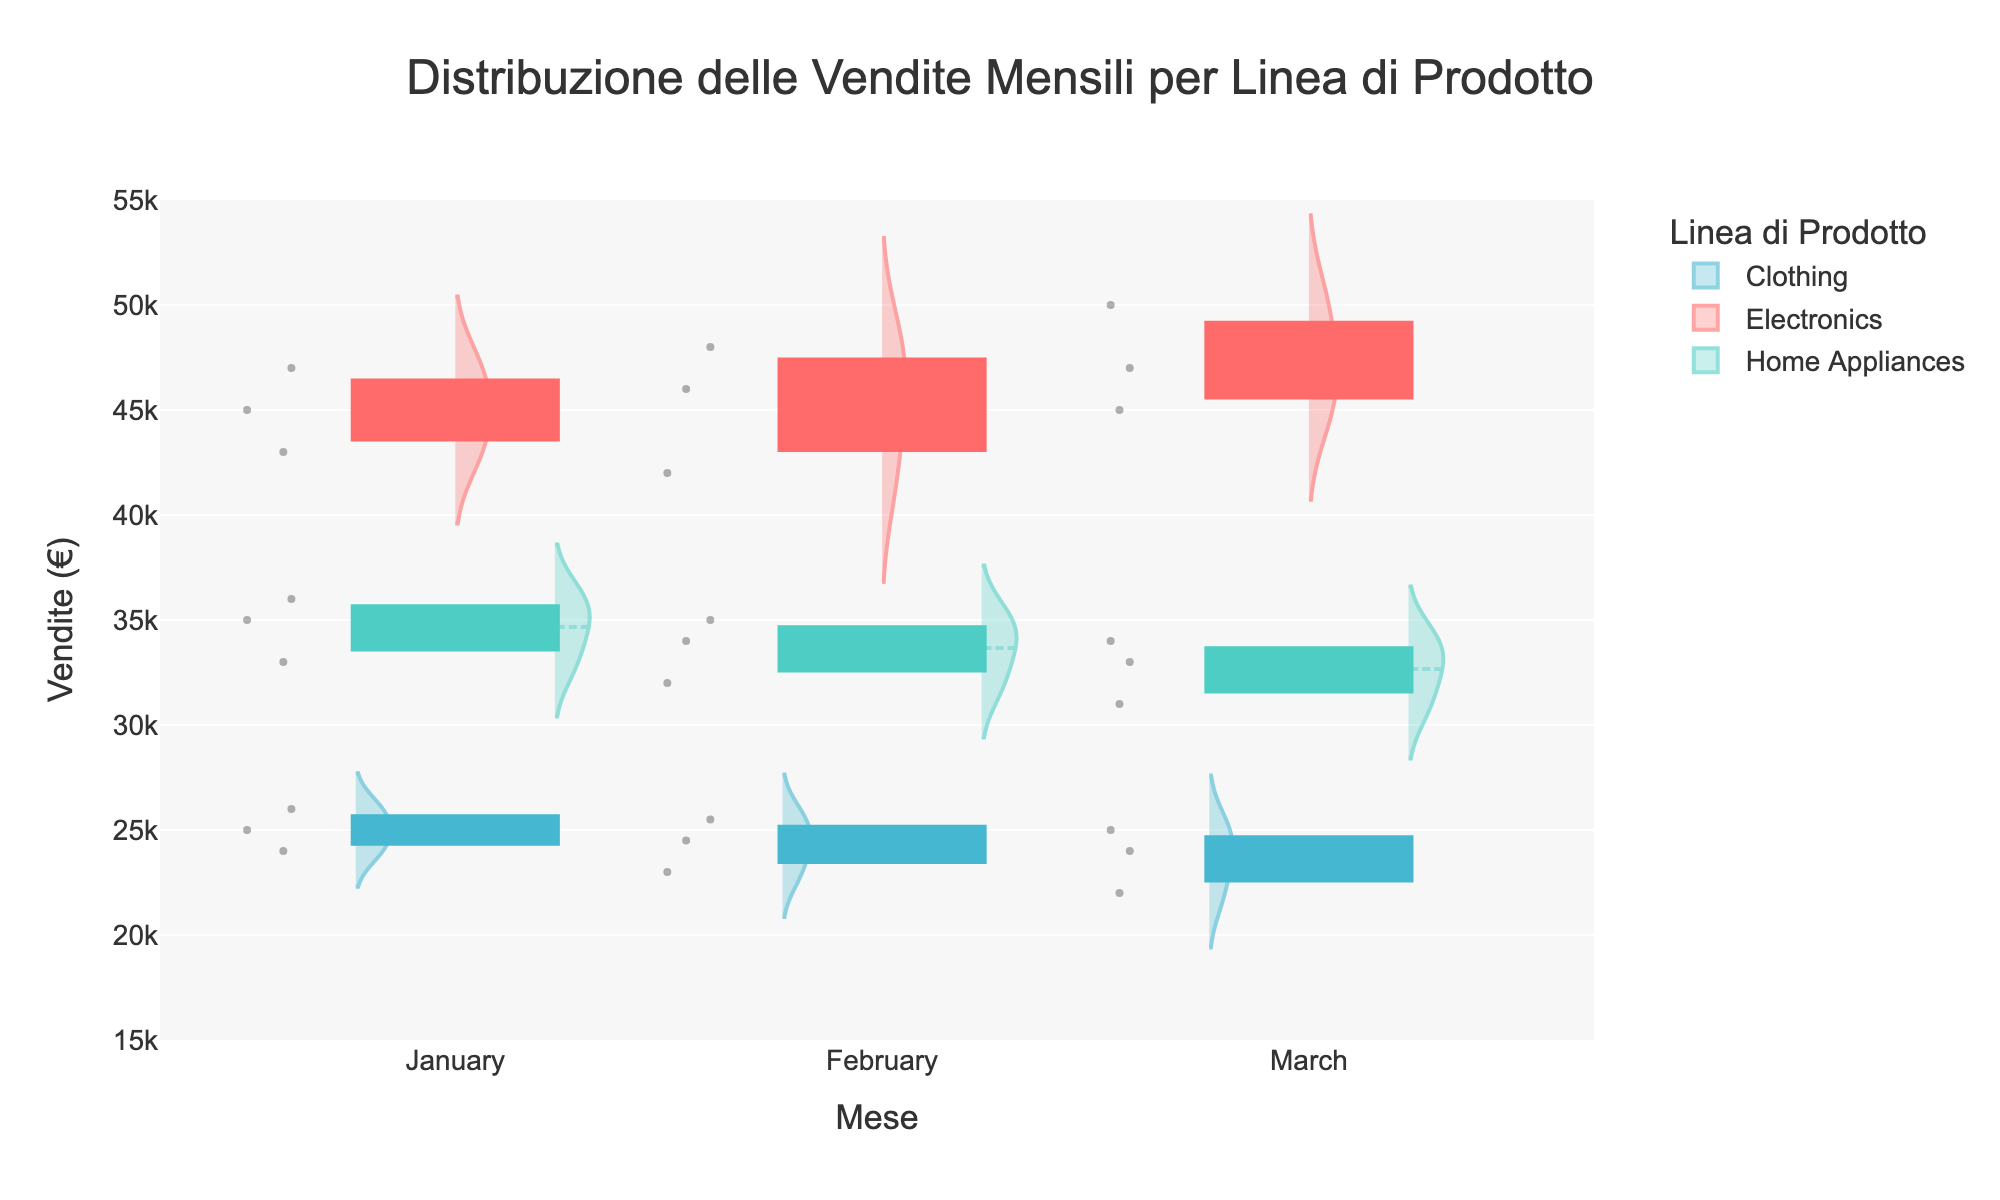What is the title of the figure? The title is positioned at the top of the figure. It reads "Distribuzione delle Vendite Mensili per Linea di Prodotto".
Answer: Distribuzione delle Vendite Mensili per Linea di Prodotto Which month has the highest sales for Electronics? In the figure, look at the median lines within the violins for each month under Electronics. The March median line is higher than those in January and February.
Answer: March What are the colors used for each product line? Refer to the legend on the right side of the figure. Electronics is red, Home Appliances is green, and Clothing is blue.
Answer: Electronics: Red, Home Appliances: Green, Clothing: Blue Which product line shows the widest range of sales values in March? Check the width of each violin plot for each product line in March. The Electronics violin plot is the widest, indicating the largest spread of sales values.
Answer: Electronics What is the median sales value for Clothing in February? Locate the Clothing violin plot for February. The median value is shown by a dashed line inside the violin. It appears near €24,500.
Answer: €24,500 Are sales values for Home Appliances more consistent in January or February? Look at the Home Appliances violin plots for January and February. The January plot is narrower, indicating more consistent sales values.
Answer: January Do any product lines show an increase in median sales from January to March? Compare the median lines across months for each product line. Both Electronics and Home Appliances show an increase, whereas Clothing does not.
Answer: Electronics and Home Appliances Which month has the lowest customer satisfaction for Clothing? While customer satisfaction ratings aren't directly plotted, we can infer from the sales data. Look at the Clothing sales in March; they are the lowest, likely reflecting lower customer satisfaction.
Answer: March In which month do Home Appliances have the highest spread in sales values? Observe the spread of the Home Appliances violin plots. The February plot shows a wider spread compared to January and March.
Answer: February What is the mean line visible in the violin plots, and what does it represent? The mean line is a solid horizontal line within each violin. It represents the average sales value for the respective product line and month.
Answer: Average sales value 